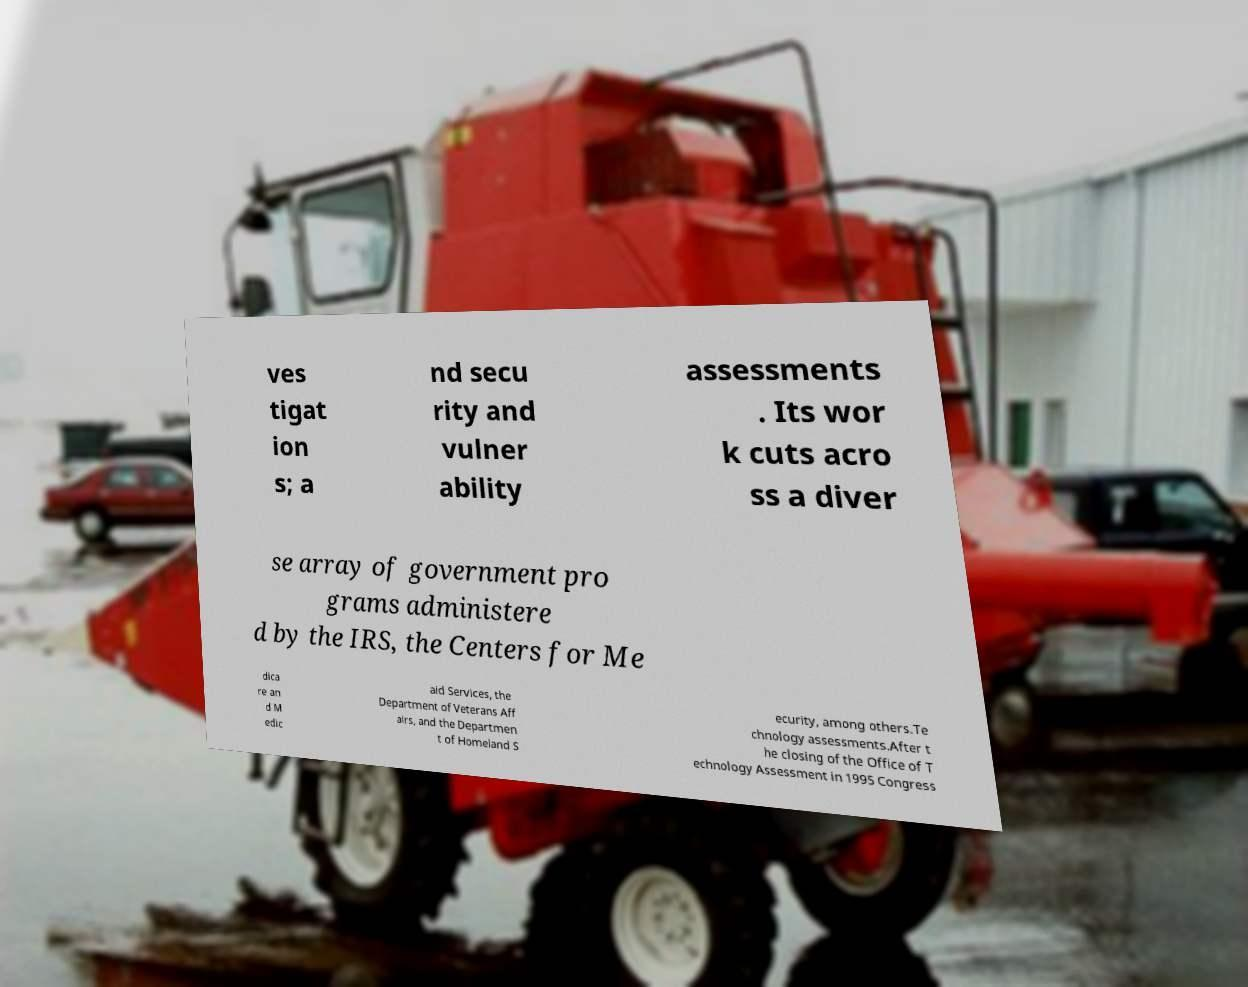Could you assist in decoding the text presented in this image and type it out clearly? ves tigat ion s; a nd secu rity and vulner ability assessments . Its wor k cuts acro ss a diver se array of government pro grams administere d by the IRS, the Centers for Me dica re an d M edic aid Services, the Department of Veterans Aff airs, and the Departmen t of Homeland S ecurity, among others.Te chnology assessments.After t he closing of the Office of T echnology Assessment in 1995 Congress 